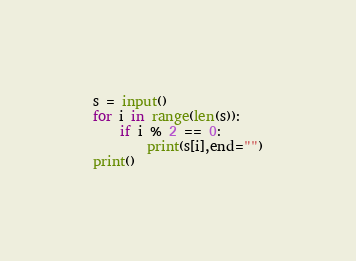<code> <loc_0><loc_0><loc_500><loc_500><_Python_>s = input()
for i in range(len(s)):
    if i % 2 == 0:
        print(s[i],end="")
print()</code> 